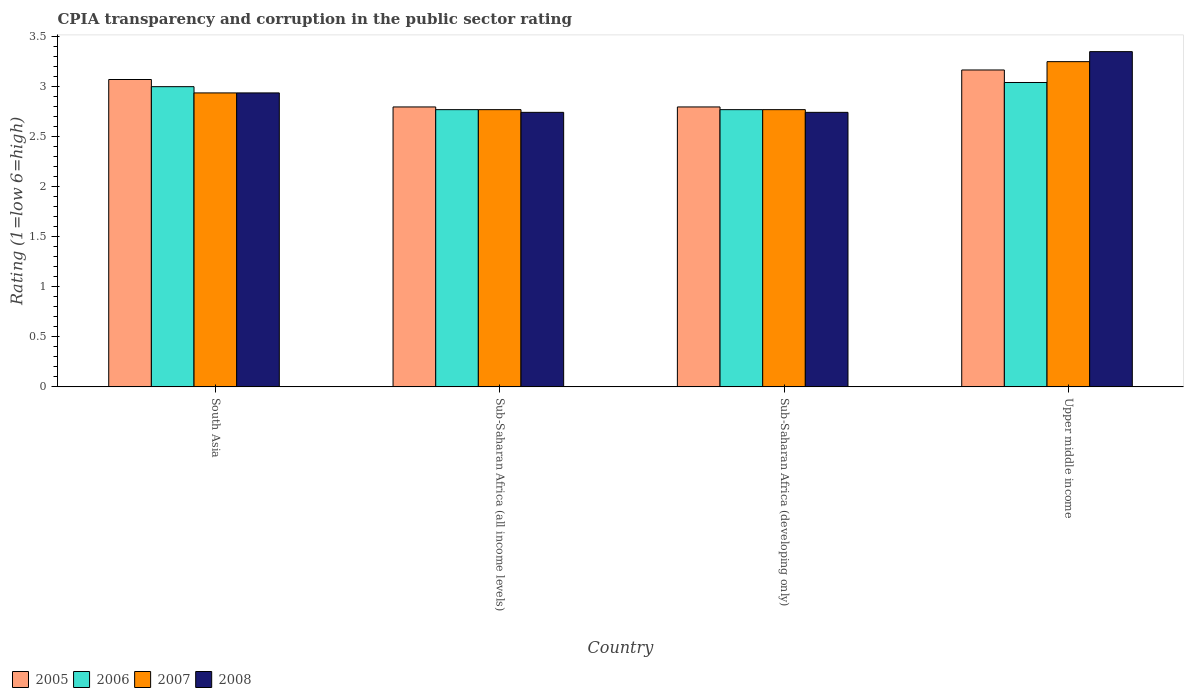How many different coloured bars are there?
Ensure brevity in your answer.  4. Are the number of bars per tick equal to the number of legend labels?
Provide a succinct answer. Yes. Are the number of bars on each tick of the X-axis equal?
Offer a very short reply. Yes. How many bars are there on the 2nd tick from the right?
Make the answer very short. 4. What is the label of the 3rd group of bars from the left?
Ensure brevity in your answer.  Sub-Saharan Africa (developing only). In how many cases, is the number of bars for a given country not equal to the number of legend labels?
Offer a very short reply. 0. What is the CPIA rating in 2006 in Upper middle income?
Provide a succinct answer. 3.04. Across all countries, what is the minimum CPIA rating in 2008?
Give a very brief answer. 2.74. In which country was the CPIA rating in 2007 maximum?
Keep it short and to the point. Upper middle income. In which country was the CPIA rating in 2007 minimum?
Make the answer very short. Sub-Saharan Africa (all income levels). What is the total CPIA rating in 2008 in the graph?
Provide a short and direct response. 11.77. What is the difference between the CPIA rating in 2007 in Sub-Saharan Africa (all income levels) and that in Upper middle income?
Your answer should be compact. -0.48. What is the difference between the CPIA rating in 2005 in Sub-Saharan Africa (developing only) and the CPIA rating in 2007 in Upper middle income?
Your response must be concise. -0.45. What is the average CPIA rating in 2007 per country?
Ensure brevity in your answer.  2.93. What is the difference between the CPIA rating of/in 2005 and CPIA rating of/in 2007 in Upper middle income?
Make the answer very short. -0.08. In how many countries, is the CPIA rating in 2008 greater than 2.8?
Your response must be concise. 2. Is the CPIA rating in 2005 in Sub-Saharan Africa (developing only) less than that in Upper middle income?
Make the answer very short. Yes. What is the difference between the highest and the second highest CPIA rating in 2006?
Offer a very short reply. 0.23. What is the difference between the highest and the lowest CPIA rating in 2006?
Ensure brevity in your answer.  0.27. Is the sum of the CPIA rating in 2008 in South Asia and Upper middle income greater than the maximum CPIA rating in 2005 across all countries?
Your answer should be compact. Yes. Is it the case that in every country, the sum of the CPIA rating in 2006 and CPIA rating in 2005 is greater than the sum of CPIA rating in 2008 and CPIA rating in 2007?
Give a very brief answer. No. What does the 1st bar from the left in Upper middle income represents?
Ensure brevity in your answer.  2005. How many bars are there?
Provide a succinct answer. 16. Are all the bars in the graph horizontal?
Offer a terse response. No. How many countries are there in the graph?
Your answer should be compact. 4. What is the difference between two consecutive major ticks on the Y-axis?
Your answer should be very brief. 0.5. Are the values on the major ticks of Y-axis written in scientific E-notation?
Ensure brevity in your answer.  No. Does the graph contain any zero values?
Make the answer very short. No. Where does the legend appear in the graph?
Ensure brevity in your answer.  Bottom left. How are the legend labels stacked?
Offer a terse response. Horizontal. What is the title of the graph?
Ensure brevity in your answer.  CPIA transparency and corruption in the public sector rating. What is the label or title of the X-axis?
Your answer should be very brief. Country. What is the Rating (1=low 6=high) in 2005 in South Asia?
Offer a very short reply. 3.07. What is the Rating (1=low 6=high) of 2006 in South Asia?
Provide a succinct answer. 3. What is the Rating (1=low 6=high) of 2007 in South Asia?
Offer a terse response. 2.94. What is the Rating (1=low 6=high) in 2008 in South Asia?
Offer a terse response. 2.94. What is the Rating (1=low 6=high) in 2005 in Sub-Saharan Africa (all income levels)?
Give a very brief answer. 2.8. What is the Rating (1=low 6=high) of 2006 in Sub-Saharan Africa (all income levels)?
Offer a very short reply. 2.77. What is the Rating (1=low 6=high) in 2007 in Sub-Saharan Africa (all income levels)?
Provide a short and direct response. 2.77. What is the Rating (1=low 6=high) in 2008 in Sub-Saharan Africa (all income levels)?
Give a very brief answer. 2.74. What is the Rating (1=low 6=high) of 2005 in Sub-Saharan Africa (developing only)?
Your answer should be very brief. 2.8. What is the Rating (1=low 6=high) of 2006 in Sub-Saharan Africa (developing only)?
Provide a succinct answer. 2.77. What is the Rating (1=low 6=high) in 2007 in Sub-Saharan Africa (developing only)?
Make the answer very short. 2.77. What is the Rating (1=low 6=high) of 2008 in Sub-Saharan Africa (developing only)?
Ensure brevity in your answer.  2.74. What is the Rating (1=low 6=high) in 2005 in Upper middle income?
Provide a succinct answer. 3.17. What is the Rating (1=low 6=high) in 2006 in Upper middle income?
Offer a terse response. 3.04. What is the Rating (1=low 6=high) of 2008 in Upper middle income?
Make the answer very short. 3.35. Across all countries, what is the maximum Rating (1=low 6=high) of 2005?
Your answer should be very brief. 3.17. Across all countries, what is the maximum Rating (1=low 6=high) in 2006?
Offer a terse response. 3.04. Across all countries, what is the maximum Rating (1=low 6=high) of 2007?
Provide a succinct answer. 3.25. Across all countries, what is the maximum Rating (1=low 6=high) of 2008?
Provide a succinct answer. 3.35. Across all countries, what is the minimum Rating (1=low 6=high) in 2005?
Keep it short and to the point. 2.8. Across all countries, what is the minimum Rating (1=low 6=high) of 2006?
Keep it short and to the point. 2.77. Across all countries, what is the minimum Rating (1=low 6=high) in 2007?
Provide a succinct answer. 2.77. Across all countries, what is the minimum Rating (1=low 6=high) of 2008?
Ensure brevity in your answer.  2.74. What is the total Rating (1=low 6=high) of 2005 in the graph?
Your response must be concise. 11.83. What is the total Rating (1=low 6=high) of 2006 in the graph?
Keep it short and to the point. 11.58. What is the total Rating (1=low 6=high) in 2007 in the graph?
Offer a very short reply. 11.73. What is the total Rating (1=low 6=high) of 2008 in the graph?
Your response must be concise. 11.77. What is the difference between the Rating (1=low 6=high) in 2005 in South Asia and that in Sub-Saharan Africa (all income levels)?
Offer a terse response. 0.27. What is the difference between the Rating (1=low 6=high) in 2006 in South Asia and that in Sub-Saharan Africa (all income levels)?
Make the answer very short. 0.23. What is the difference between the Rating (1=low 6=high) in 2007 in South Asia and that in Sub-Saharan Africa (all income levels)?
Offer a terse response. 0.17. What is the difference between the Rating (1=low 6=high) in 2008 in South Asia and that in Sub-Saharan Africa (all income levels)?
Provide a succinct answer. 0.19. What is the difference between the Rating (1=low 6=high) in 2005 in South Asia and that in Sub-Saharan Africa (developing only)?
Ensure brevity in your answer.  0.27. What is the difference between the Rating (1=low 6=high) in 2006 in South Asia and that in Sub-Saharan Africa (developing only)?
Provide a succinct answer. 0.23. What is the difference between the Rating (1=low 6=high) in 2007 in South Asia and that in Sub-Saharan Africa (developing only)?
Your answer should be very brief. 0.17. What is the difference between the Rating (1=low 6=high) of 2008 in South Asia and that in Sub-Saharan Africa (developing only)?
Ensure brevity in your answer.  0.19. What is the difference between the Rating (1=low 6=high) of 2005 in South Asia and that in Upper middle income?
Make the answer very short. -0.1. What is the difference between the Rating (1=low 6=high) in 2006 in South Asia and that in Upper middle income?
Your answer should be compact. -0.04. What is the difference between the Rating (1=low 6=high) in 2007 in South Asia and that in Upper middle income?
Your answer should be compact. -0.31. What is the difference between the Rating (1=low 6=high) of 2008 in South Asia and that in Upper middle income?
Your answer should be compact. -0.41. What is the difference between the Rating (1=low 6=high) in 2005 in Sub-Saharan Africa (all income levels) and that in Sub-Saharan Africa (developing only)?
Your answer should be compact. 0. What is the difference between the Rating (1=low 6=high) of 2006 in Sub-Saharan Africa (all income levels) and that in Sub-Saharan Africa (developing only)?
Ensure brevity in your answer.  0. What is the difference between the Rating (1=low 6=high) of 2005 in Sub-Saharan Africa (all income levels) and that in Upper middle income?
Provide a short and direct response. -0.37. What is the difference between the Rating (1=low 6=high) in 2006 in Sub-Saharan Africa (all income levels) and that in Upper middle income?
Your answer should be very brief. -0.27. What is the difference between the Rating (1=low 6=high) of 2007 in Sub-Saharan Africa (all income levels) and that in Upper middle income?
Offer a very short reply. -0.48. What is the difference between the Rating (1=low 6=high) in 2008 in Sub-Saharan Africa (all income levels) and that in Upper middle income?
Provide a short and direct response. -0.61. What is the difference between the Rating (1=low 6=high) in 2005 in Sub-Saharan Africa (developing only) and that in Upper middle income?
Your response must be concise. -0.37. What is the difference between the Rating (1=low 6=high) of 2006 in Sub-Saharan Africa (developing only) and that in Upper middle income?
Ensure brevity in your answer.  -0.27. What is the difference between the Rating (1=low 6=high) in 2007 in Sub-Saharan Africa (developing only) and that in Upper middle income?
Your answer should be compact. -0.48. What is the difference between the Rating (1=low 6=high) in 2008 in Sub-Saharan Africa (developing only) and that in Upper middle income?
Your response must be concise. -0.61. What is the difference between the Rating (1=low 6=high) in 2005 in South Asia and the Rating (1=low 6=high) in 2006 in Sub-Saharan Africa (all income levels)?
Your answer should be compact. 0.3. What is the difference between the Rating (1=low 6=high) in 2005 in South Asia and the Rating (1=low 6=high) in 2007 in Sub-Saharan Africa (all income levels)?
Offer a very short reply. 0.3. What is the difference between the Rating (1=low 6=high) in 2005 in South Asia and the Rating (1=low 6=high) in 2008 in Sub-Saharan Africa (all income levels)?
Offer a terse response. 0.33. What is the difference between the Rating (1=low 6=high) of 2006 in South Asia and the Rating (1=low 6=high) of 2007 in Sub-Saharan Africa (all income levels)?
Give a very brief answer. 0.23. What is the difference between the Rating (1=low 6=high) in 2006 in South Asia and the Rating (1=low 6=high) in 2008 in Sub-Saharan Africa (all income levels)?
Provide a short and direct response. 0.26. What is the difference between the Rating (1=low 6=high) in 2007 in South Asia and the Rating (1=low 6=high) in 2008 in Sub-Saharan Africa (all income levels)?
Provide a succinct answer. 0.19. What is the difference between the Rating (1=low 6=high) of 2005 in South Asia and the Rating (1=low 6=high) of 2006 in Sub-Saharan Africa (developing only)?
Your answer should be very brief. 0.3. What is the difference between the Rating (1=low 6=high) in 2005 in South Asia and the Rating (1=low 6=high) in 2007 in Sub-Saharan Africa (developing only)?
Make the answer very short. 0.3. What is the difference between the Rating (1=low 6=high) in 2005 in South Asia and the Rating (1=low 6=high) in 2008 in Sub-Saharan Africa (developing only)?
Make the answer very short. 0.33. What is the difference between the Rating (1=low 6=high) of 2006 in South Asia and the Rating (1=low 6=high) of 2007 in Sub-Saharan Africa (developing only)?
Offer a very short reply. 0.23. What is the difference between the Rating (1=low 6=high) in 2006 in South Asia and the Rating (1=low 6=high) in 2008 in Sub-Saharan Africa (developing only)?
Offer a terse response. 0.26. What is the difference between the Rating (1=low 6=high) in 2007 in South Asia and the Rating (1=low 6=high) in 2008 in Sub-Saharan Africa (developing only)?
Offer a terse response. 0.19. What is the difference between the Rating (1=low 6=high) of 2005 in South Asia and the Rating (1=low 6=high) of 2006 in Upper middle income?
Your answer should be very brief. 0.03. What is the difference between the Rating (1=low 6=high) of 2005 in South Asia and the Rating (1=low 6=high) of 2007 in Upper middle income?
Keep it short and to the point. -0.18. What is the difference between the Rating (1=low 6=high) in 2005 in South Asia and the Rating (1=low 6=high) in 2008 in Upper middle income?
Your answer should be compact. -0.28. What is the difference between the Rating (1=low 6=high) in 2006 in South Asia and the Rating (1=low 6=high) in 2008 in Upper middle income?
Provide a succinct answer. -0.35. What is the difference between the Rating (1=low 6=high) of 2007 in South Asia and the Rating (1=low 6=high) of 2008 in Upper middle income?
Ensure brevity in your answer.  -0.41. What is the difference between the Rating (1=low 6=high) of 2005 in Sub-Saharan Africa (all income levels) and the Rating (1=low 6=high) of 2006 in Sub-Saharan Africa (developing only)?
Keep it short and to the point. 0.03. What is the difference between the Rating (1=low 6=high) in 2005 in Sub-Saharan Africa (all income levels) and the Rating (1=low 6=high) in 2007 in Sub-Saharan Africa (developing only)?
Your answer should be very brief. 0.03. What is the difference between the Rating (1=low 6=high) of 2005 in Sub-Saharan Africa (all income levels) and the Rating (1=low 6=high) of 2008 in Sub-Saharan Africa (developing only)?
Ensure brevity in your answer.  0.05. What is the difference between the Rating (1=low 6=high) in 2006 in Sub-Saharan Africa (all income levels) and the Rating (1=low 6=high) in 2008 in Sub-Saharan Africa (developing only)?
Your answer should be very brief. 0.03. What is the difference between the Rating (1=low 6=high) in 2007 in Sub-Saharan Africa (all income levels) and the Rating (1=low 6=high) in 2008 in Sub-Saharan Africa (developing only)?
Provide a short and direct response. 0.03. What is the difference between the Rating (1=low 6=high) of 2005 in Sub-Saharan Africa (all income levels) and the Rating (1=low 6=high) of 2006 in Upper middle income?
Your answer should be very brief. -0.24. What is the difference between the Rating (1=low 6=high) of 2005 in Sub-Saharan Africa (all income levels) and the Rating (1=low 6=high) of 2007 in Upper middle income?
Provide a short and direct response. -0.45. What is the difference between the Rating (1=low 6=high) in 2005 in Sub-Saharan Africa (all income levels) and the Rating (1=low 6=high) in 2008 in Upper middle income?
Keep it short and to the point. -0.55. What is the difference between the Rating (1=low 6=high) in 2006 in Sub-Saharan Africa (all income levels) and the Rating (1=low 6=high) in 2007 in Upper middle income?
Provide a succinct answer. -0.48. What is the difference between the Rating (1=low 6=high) of 2006 in Sub-Saharan Africa (all income levels) and the Rating (1=low 6=high) of 2008 in Upper middle income?
Give a very brief answer. -0.58. What is the difference between the Rating (1=low 6=high) of 2007 in Sub-Saharan Africa (all income levels) and the Rating (1=low 6=high) of 2008 in Upper middle income?
Provide a short and direct response. -0.58. What is the difference between the Rating (1=low 6=high) of 2005 in Sub-Saharan Africa (developing only) and the Rating (1=low 6=high) of 2006 in Upper middle income?
Ensure brevity in your answer.  -0.24. What is the difference between the Rating (1=low 6=high) in 2005 in Sub-Saharan Africa (developing only) and the Rating (1=low 6=high) in 2007 in Upper middle income?
Provide a succinct answer. -0.45. What is the difference between the Rating (1=low 6=high) in 2005 in Sub-Saharan Africa (developing only) and the Rating (1=low 6=high) in 2008 in Upper middle income?
Ensure brevity in your answer.  -0.55. What is the difference between the Rating (1=low 6=high) of 2006 in Sub-Saharan Africa (developing only) and the Rating (1=low 6=high) of 2007 in Upper middle income?
Keep it short and to the point. -0.48. What is the difference between the Rating (1=low 6=high) of 2006 in Sub-Saharan Africa (developing only) and the Rating (1=low 6=high) of 2008 in Upper middle income?
Keep it short and to the point. -0.58. What is the difference between the Rating (1=low 6=high) of 2007 in Sub-Saharan Africa (developing only) and the Rating (1=low 6=high) of 2008 in Upper middle income?
Offer a terse response. -0.58. What is the average Rating (1=low 6=high) of 2005 per country?
Ensure brevity in your answer.  2.96. What is the average Rating (1=low 6=high) in 2006 per country?
Make the answer very short. 2.9. What is the average Rating (1=low 6=high) in 2007 per country?
Offer a terse response. 2.93. What is the average Rating (1=low 6=high) in 2008 per country?
Offer a terse response. 2.94. What is the difference between the Rating (1=low 6=high) of 2005 and Rating (1=low 6=high) of 2006 in South Asia?
Offer a very short reply. 0.07. What is the difference between the Rating (1=low 6=high) in 2005 and Rating (1=low 6=high) in 2007 in South Asia?
Your answer should be compact. 0.13. What is the difference between the Rating (1=low 6=high) in 2005 and Rating (1=low 6=high) in 2008 in South Asia?
Keep it short and to the point. 0.13. What is the difference between the Rating (1=low 6=high) of 2006 and Rating (1=low 6=high) of 2007 in South Asia?
Provide a short and direct response. 0.06. What is the difference between the Rating (1=low 6=high) of 2006 and Rating (1=low 6=high) of 2008 in South Asia?
Keep it short and to the point. 0.06. What is the difference between the Rating (1=low 6=high) of 2005 and Rating (1=low 6=high) of 2006 in Sub-Saharan Africa (all income levels)?
Give a very brief answer. 0.03. What is the difference between the Rating (1=low 6=high) in 2005 and Rating (1=low 6=high) in 2007 in Sub-Saharan Africa (all income levels)?
Offer a very short reply. 0.03. What is the difference between the Rating (1=low 6=high) in 2005 and Rating (1=low 6=high) in 2008 in Sub-Saharan Africa (all income levels)?
Keep it short and to the point. 0.05. What is the difference between the Rating (1=low 6=high) of 2006 and Rating (1=low 6=high) of 2007 in Sub-Saharan Africa (all income levels)?
Your answer should be very brief. 0. What is the difference between the Rating (1=low 6=high) in 2006 and Rating (1=low 6=high) in 2008 in Sub-Saharan Africa (all income levels)?
Ensure brevity in your answer.  0.03. What is the difference between the Rating (1=low 6=high) of 2007 and Rating (1=low 6=high) of 2008 in Sub-Saharan Africa (all income levels)?
Make the answer very short. 0.03. What is the difference between the Rating (1=low 6=high) of 2005 and Rating (1=low 6=high) of 2006 in Sub-Saharan Africa (developing only)?
Make the answer very short. 0.03. What is the difference between the Rating (1=low 6=high) in 2005 and Rating (1=low 6=high) in 2007 in Sub-Saharan Africa (developing only)?
Offer a terse response. 0.03. What is the difference between the Rating (1=low 6=high) in 2005 and Rating (1=low 6=high) in 2008 in Sub-Saharan Africa (developing only)?
Keep it short and to the point. 0.05. What is the difference between the Rating (1=low 6=high) in 2006 and Rating (1=low 6=high) in 2008 in Sub-Saharan Africa (developing only)?
Keep it short and to the point. 0.03. What is the difference between the Rating (1=low 6=high) of 2007 and Rating (1=low 6=high) of 2008 in Sub-Saharan Africa (developing only)?
Your answer should be compact. 0.03. What is the difference between the Rating (1=low 6=high) of 2005 and Rating (1=low 6=high) of 2007 in Upper middle income?
Provide a succinct answer. -0.08. What is the difference between the Rating (1=low 6=high) in 2005 and Rating (1=low 6=high) in 2008 in Upper middle income?
Your response must be concise. -0.18. What is the difference between the Rating (1=low 6=high) of 2006 and Rating (1=low 6=high) of 2007 in Upper middle income?
Keep it short and to the point. -0.21. What is the difference between the Rating (1=low 6=high) of 2006 and Rating (1=low 6=high) of 2008 in Upper middle income?
Your response must be concise. -0.31. What is the ratio of the Rating (1=low 6=high) in 2005 in South Asia to that in Sub-Saharan Africa (all income levels)?
Provide a succinct answer. 1.1. What is the ratio of the Rating (1=low 6=high) of 2006 in South Asia to that in Sub-Saharan Africa (all income levels)?
Keep it short and to the point. 1.08. What is the ratio of the Rating (1=low 6=high) of 2007 in South Asia to that in Sub-Saharan Africa (all income levels)?
Your answer should be very brief. 1.06. What is the ratio of the Rating (1=low 6=high) in 2008 in South Asia to that in Sub-Saharan Africa (all income levels)?
Offer a terse response. 1.07. What is the ratio of the Rating (1=low 6=high) in 2005 in South Asia to that in Sub-Saharan Africa (developing only)?
Make the answer very short. 1.1. What is the ratio of the Rating (1=low 6=high) in 2006 in South Asia to that in Sub-Saharan Africa (developing only)?
Ensure brevity in your answer.  1.08. What is the ratio of the Rating (1=low 6=high) of 2007 in South Asia to that in Sub-Saharan Africa (developing only)?
Your response must be concise. 1.06. What is the ratio of the Rating (1=low 6=high) of 2008 in South Asia to that in Sub-Saharan Africa (developing only)?
Keep it short and to the point. 1.07. What is the ratio of the Rating (1=low 6=high) of 2005 in South Asia to that in Upper middle income?
Keep it short and to the point. 0.97. What is the ratio of the Rating (1=low 6=high) in 2006 in South Asia to that in Upper middle income?
Offer a terse response. 0.99. What is the ratio of the Rating (1=low 6=high) in 2007 in South Asia to that in Upper middle income?
Give a very brief answer. 0.9. What is the ratio of the Rating (1=low 6=high) of 2008 in South Asia to that in Upper middle income?
Your answer should be compact. 0.88. What is the ratio of the Rating (1=low 6=high) in 2005 in Sub-Saharan Africa (all income levels) to that in Sub-Saharan Africa (developing only)?
Ensure brevity in your answer.  1. What is the ratio of the Rating (1=low 6=high) in 2007 in Sub-Saharan Africa (all income levels) to that in Sub-Saharan Africa (developing only)?
Your response must be concise. 1. What is the ratio of the Rating (1=low 6=high) in 2005 in Sub-Saharan Africa (all income levels) to that in Upper middle income?
Your answer should be very brief. 0.88. What is the ratio of the Rating (1=low 6=high) of 2006 in Sub-Saharan Africa (all income levels) to that in Upper middle income?
Offer a very short reply. 0.91. What is the ratio of the Rating (1=low 6=high) of 2007 in Sub-Saharan Africa (all income levels) to that in Upper middle income?
Offer a very short reply. 0.85. What is the ratio of the Rating (1=low 6=high) in 2008 in Sub-Saharan Africa (all income levels) to that in Upper middle income?
Offer a very short reply. 0.82. What is the ratio of the Rating (1=low 6=high) in 2005 in Sub-Saharan Africa (developing only) to that in Upper middle income?
Offer a very short reply. 0.88. What is the ratio of the Rating (1=low 6=high) in 2006 in Sub-Saharan Africa (developing only) to that in Upper middle income?
Make the answer very short. 0.91. What is the ratio of the Rating (1=low 6=high) in 2007 in Sub-Saharan Africa (developing only) to that in Upper middle income?
Offer a very short reply. 0.85. What is the ratio of the Rating (1=low 6=high) in 2008 in Sub-Saharan Africa (developing only) to that in Upper middle income?
Your response must be concise. 0.82. What is the difference between the highest and the second highest Rating (1=low 6=high) of 2005?
Offer a terse response. 0.1. What is the difference between the highest and the second highest Rating (1=low 6=high) in 2006?
Offer a terse response. 0.04. What is the difference between the highest and the second highest Rating (1=low 6=high) in 2007?
Provide a short and direct response. 0.31. What is the difference between the highest and the second highest Rating (1=low 6=high) of 2008?
Keep it short and to the point. 0.41. What is the difference between the highest and the lowest Rating (1=low 6=high) of 2005?
Provide a succinct answer. 0.37. What is the difference between the highest and the lowest Rating (1=low 6=high) of 2006?
Ensure brevity in your answer.  0.27. What is the difference between the highest and the lowest Rating (1=low 6=high) in 2007?
Provide a succinct answer. 0.48. What is the difference between the highest and the lowest Rating (1=low 6=high) of 2008?
Offer a terse response. 0.61. 